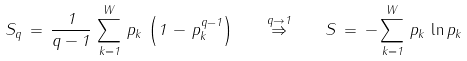<formula> <loc_0><loc_0><loc_500><loc_500>S _ { q } \, = \, \frac { 1 } { q - 1 } \, \sum ^ { W } _ { k = 1 } \, p _ { k } \, \left ( 1 \, - \, p ^ { q - 1 } _ { k } \right ) \quad \stackrel { q \rightarrow 1 } { \Rightarrow } \quad S \, = \, - \sum ^ { W } _ { k = 1 } \, p _ { k } \, \ln p _ { k }</formula> 